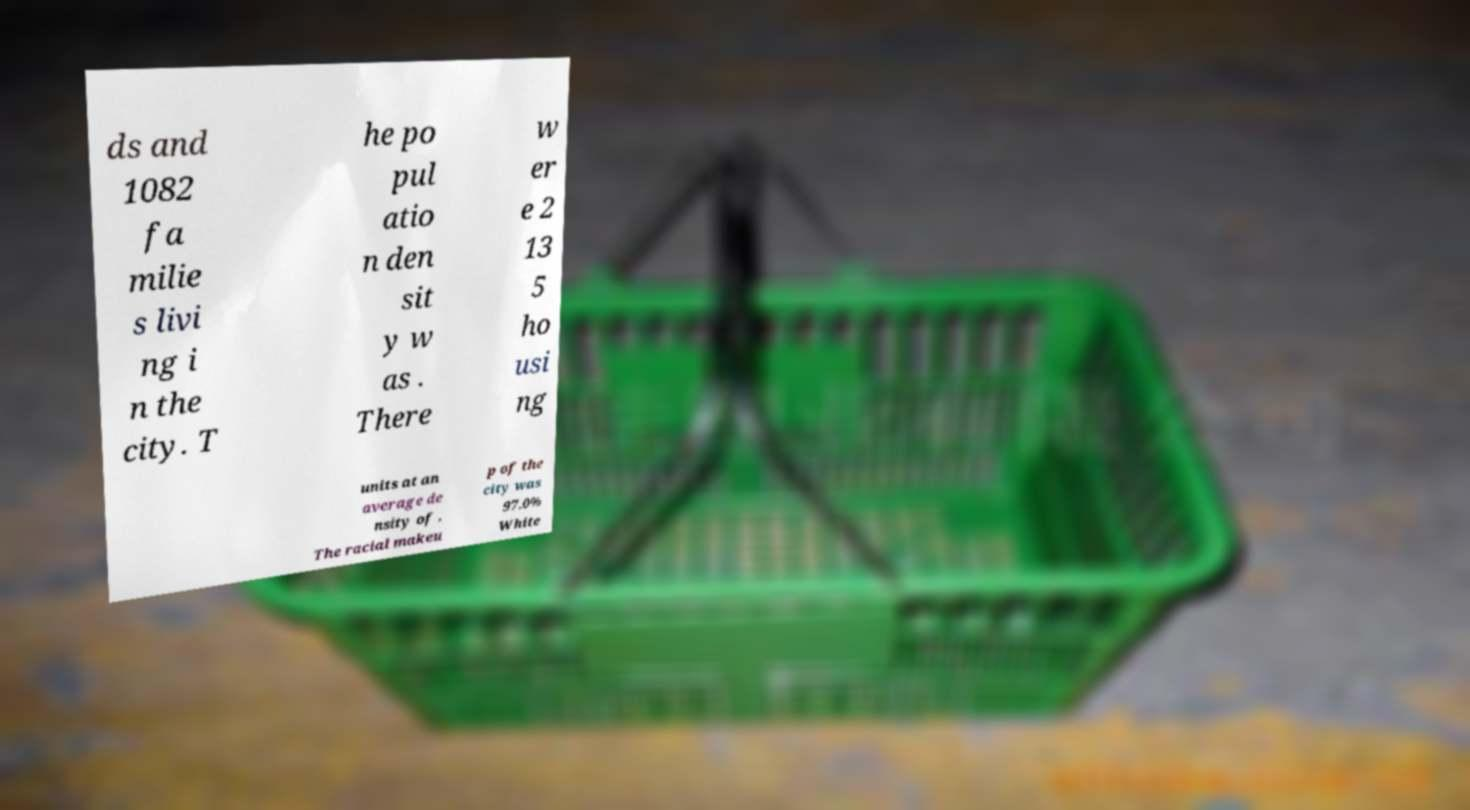Could you extract and type out the text from this image? ds and 1082 fa milie s livi ng i n the city. T he po pul atio n den sit y w as . There w er e 2 13 5 ho usi ng units at an average de nsity of . The racial makeu p of the city was 97.0% White 